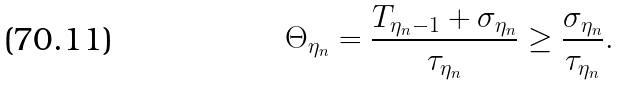Convert formula to latex. <formula><loc_0><loc_0><loc_500><loc_500>\Theta _ { \eta _ { n } } = \frac { T _ { \eta _ { n } - 1 } + \sigma _ { \eta _ { n } } } { \tau _ { \eta _ { n } } } \geq \frac { \sigma _ { \eta _ { n } } } { \tau _ { \eta _ { n } } } .</formula> 